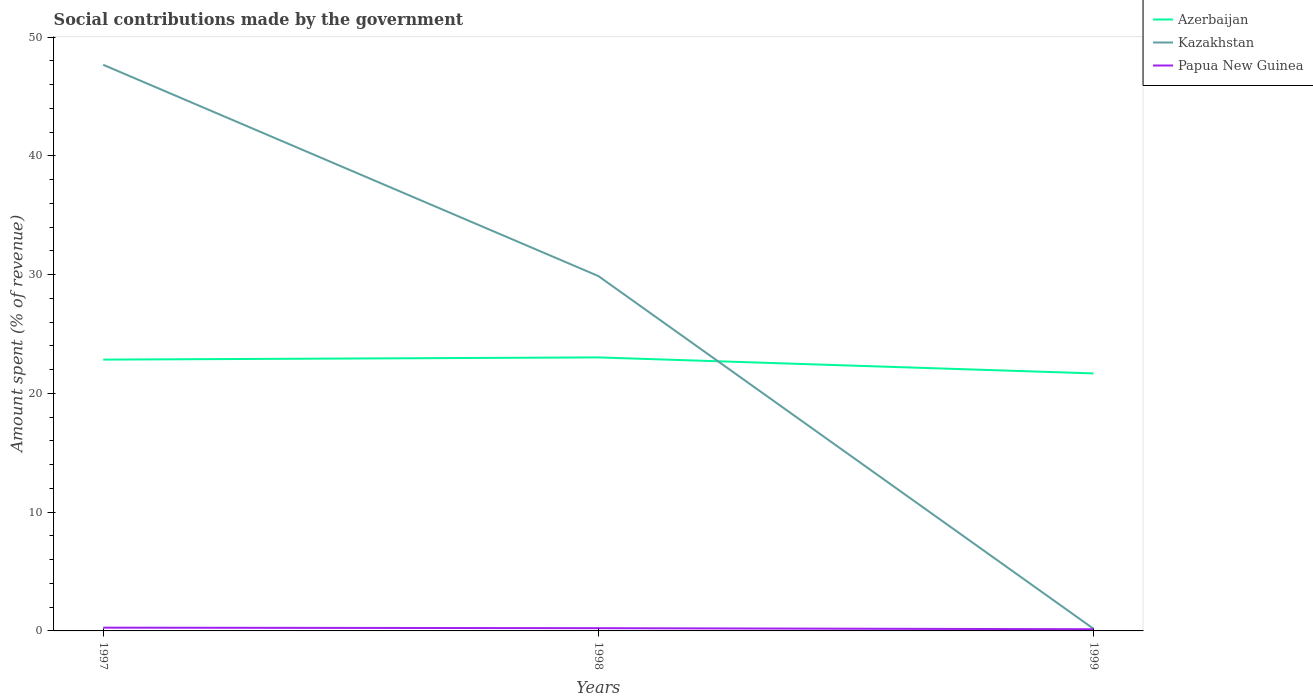Across all years, what is the maximum amount spent (in %) on social contributions in Azerbaijan?
Keep it short and to the point. 21.69. In which year was the amount spent (in %) on social contributions in Azerbaijan maximum?
Make the answer very short. 1999. What is the total amount spent (in %) on social contributions in Kazakhstan in the graph?
Keep it short and to the point. 17.79. What is the difference between the highest and the second highest amount spent (in %) on social contributions in Azerbaijan?
Your answer should be compact. 1.35. Is the amount spent (in %) on social contributions in Papua New Guinea strictly greater than the amount spent (in %) on social contributions in Azerbaijan over the years?
Your answer should be compact. Yes. How many lines are there?
Ensure brevity in your answer.  3. How many years are there in the graph?
Ensure brevity in your answer.  3. How are the legend labels stacked?
Ensure brevity in your answer.  Vertical. What is the title of the graph?
Your answer should be very brief. Social contributions made by the government. Does "Australia" appear as one of the legend labels in the graph?
Give a very brief answer. No. What is the label or title of the X-axis?
Offer a terse response. Years. What is the label or title of the Y-axis?
Provide a succinct answer. Amount spent (% of revenue). What is the Amount spent (% of revenue) of Azerbaijan in 1997?
Offer a very short reply. 22.85. What is the Amount spent (% of revenue) in Kazakhstan in 1997?
Your response must be concise. 47.67. What is the Amount spent (% of revenue) of Papua New Guinea in 1997?
Offer a very short reply. 0.28. What is the Amount spent (% of revenue) in Azerbaijan in 1998?
Keep it short and to the point. 23.03. What is the Amount spent (% of revenue) of Kazakhstan in 1998?
Make the answer very short. 29.88. What is the Amount spent (% of revenue) of Papua New Guinea in 1998?
Provide a short and direct response. 0.23. What is the Amount spent (% of revenue) of Azerbaijan in 1999?
Give a very brief answer. 21.69. What is the Amount spent (% of revenue) in Kazakhstan in 1999?
Keep it short and to the point. 0.18. What is the Amount spent (% of revenue) in Papua New Guinea in 1999?
Make the answer very short. 0.14. Across all years, what is the maximum Amount spent (% of revenue) of Azerbaijan?
Ensure brevity in your answer.  23.03. Across all years, what is the maximum Amount spent (% of revenue) of Kazakhstan?
Keep it short and to the point. 47.67. Across all years, what is the maximum Amount spent (% of revenue) of Papua New Guinea?
Provide a succinct answer. 0.28. Across all years, what is the minimum Amount spent (% of revenue) of Azerbaijan?
Ensure brevity in your answer.  21.69. Across all years, what is the minimum Amount spent (% of revenue) in Kazakhstan?
Offer a very short reply. 0.18. Across all years, what is the minimum Amount spent (% of revenue) of Papua New Guinea?
Give a very brief answer. 0.14. What is the total Amount spent (% of revenue) in Azerbaijan in the graph?
Ensure brevity in your answer.  67.57. What is the total Amount spent (% of revenue) of Kazakhstan in the graph?
Make the answer very short. 77.74. What is the total Amount spent (% of revenue) in Papua New Guinea in the graph?
Ensure brevity in your answer.  0.65. What is the difference between the Amount spent (% of revenue) in Azerbaijan in 1997 and that in 1998?
Keep it short and to the point. -0.18. What is the difference between the Amount spent (% of revenue) in Kazakhstan in 1997 and that in 1998?
Your answer should be compact. 17.79. What is the difference between the Amount spent (% of revenue) in Papua New Guinea in 1997 and that in 1998?
Your response must be concise. 0.04. What is the difference between the Amount spent (% of revenue) of Azerbaijan in 1997 and that in 1999?
Provide a succinct answer. 1.16. What is the difference between the Amount spent (% of revenue) in Kazakhstan in 1997 and that in 1999?
Provide a short and direct response. 47.49. What is the difference between the Amount spent (% of revenue) of Papua New Guinea in 1997 and that in 1999?
Keep it short and to the point. 0.13. What is the difference between the Amount spent (% of revenue) in Azerbaijan in 1998 and that in 1999?
Make the answer very short. 1.35. What is the difference between the Amount spent (% of revenue) of Kazakhstan in 1998 and that in 1999?
Provide a short and direct response. 29.7. What is the difference between the Amount spent (% of revenue) of Papua New Guinea in 1998 and that in 1999?
Give a very brief answer. 0.09. What is the difference between the Amount spent (% of revenue) in Azerbaijan in 1997 and the Amount spent (% of revenue) in Kazakhstan in 1998?
Ensure brevity in your answer.  -7.04. What is the difference between the Amount spent (% of revenue) in Azerbaijan in 1997 and the Amount spent (% of revenue) in Papua New Guinea in 1998?
Give a very brief answer. 22.62. What is the difference between the Amount spent (% of revenue) in Kazakhstan in 1997 and the Amount spent (% of revenue) in Papua New Guinea in 1998?
Give a very brief answer. 47.44. What is the difference between the Amount spent (% of revenue) of Azerbaijan in 1997 and the Amount spent (% of revenue) of Kazakhstan in 1999?
Provide a succinct answer. 22.67. What is the difference between the Amount spent (% of revenue) of Azerbaijan in 1997 and the Amount spent (% of revenue) of Papua New Guinea in 1999?
Provide a succinct answer. 22.71. What is the difference between the Amount spent (% of revenue) of Kazakhstan in 1997 and the Amount spent (% of revenue) of Papua New Guinea in 1999?
Offer a very short reply. 47.53. What is the difference between the Amount spent (% of revenue) in Azerbaijan in 1998 and the Amount spent (% of revenue) in Kazakhstan in 1999?
Keep it short and to the point. 22.85. What is the difference between the Amount spent (% of revenue) in Azerbaijan in 1998 and the Amount spent (% of revenue) in Papua New Guinea in 1999?
Keep it short and to the point. 22.89. What is the difference between the Amount spent (% of revenue) of Kazakhstan in 1998 and the Amount spent (% of revenue) of Papua New Guinea in 1999?
Offer a very short reply. 29.74. What is the average Amount spent (% of revenue) in Azerbaijan per year?
Offer a terse response. 22.52. What is the average Amount spent (% of revenue) of Kazakhstan per year?
Offer a terse response. 25.91. What is the average Amount spent (% of revenue) in Papua New Guinea per year?
Offer a very short reply. 0.22. In the year 1997, what is the difference between the Amount spent (% of revenue) of Azerbaijan and Amount spent (% of revenue) of Kazakhstan?
Provide a short and direct response. -24.83. In the year 1997, what is the difference between the Amount spent (% of revenue) in Azerbaijan and Amount spent (% of revenue) in Papua New Guinea?
Make the answer very short. 22.57. In the year 1997, what is the difference between the Amount spent (% of revenue) of Kazakhstan and Amount spent (% of revenue) of Papua New Guinea?
Provide a succinct answer. 47.4. In the year 1998, what is the difference between the Amount spent (% of revenue) in Azerbaijan and Amount spent (% of revenue) in Kazakhstan?
Ensure brevity in your answer.  -6.85. In the year 1998, what is the difference between the Amount spent (% of revenue) in Azerbaijan and Amount spent (% of revenue) in Papua New Guinea?
Keep it short and to the point. 22.8. In the year 1998, what is the difference between the Amount spent (% of revenue) in Kazakhstan and Amount spent (% of revenue) in Papua New Guinea?
Give a very brief answer. 29.65. In the year 1999, what is the difference between the Amount spent (% of revenue) of Azerbaijan and Amount spent (% of revenue) of Kazakhstan?
Your answer should be very brief. 21.5. In the year 1999, what is the difference between the Amount spent (% of revenue) in Azerbaijan and Amount spent (% of revenue) in Papua New Guinea?
Your response must be concise. 21.54. In the year 1999, what is the difference between the Amount spent (% of revenue) of Kazakhstan and Amount spent (% of revenue) of Papua New Guinea?
Make the answer very short. 0.04. What is the ratio of the Amount spent (% of revenue) of Azerbaijan in 1997 to that in 1998?
Make the answer very short. 0.99. What is the ratio of the Amount spent (% of revenue) in Kazakhstan in 1997 to that in 1998?
Your response must be concise. 1.6. What is the ratio of the Amount spent (% of revenue) in Papua New Guinea in 1997 to that in 1998?
Ensure brevity in your answer.  1.19. What is the ratio of the Amount spent (% of revenue) of Azerbaijan in 1997 to that in 1999?
Keep it short and to the point. 1.05. What is the ratio of the Amount spent (% of revenue) in Kazakhstan in 1997 to that in 1999?
Make the answer very short. 263.04. What is the ratio of the Amount spent (% of revenue) of Papua New Guinea in 1997 to that in 1999?
Provide a short and direct response. 1.94. What is the ratio of the Amount spent (% of revenue) in Azerbaijan in 1998 to that in 1999?
Ensure brevity in your answer.  1.06. What is the ratio of the Amount spent (% of revenue) in Kazakhstan in 1998 to that in 1999?
Provide a succinct answer. 164.88. What is the ratio of the Amount spent (% of revenue) of Papua New Guinea in 1998 to that in 1999?
Provide a succinct answer. 1.63. What is the difference between the highest and the second highest Amount spent (% of revenue) of Azerbaijan?
Your answer should be very brief. 0.18. What is the difference between the highest and the second highest Amount spent (% of revenue) of Kazakhstan?
Provide a succinct answer. 17.79. What is the difference between the highest and the second highest Amount spent (% of revenue) in Papua New Guinea?
Your answer should be very brief. 0.04. What is the difference between the highest and the lowest Amount spent (% of revenue) of Azerbaijan?
Make the answer very short. 1.35. What is the difference between the highest and the lowest Amount spent (% of revenue) in Kazakhstan?
Your answer should be compact. 47.49. What is the difference between the highest and the lowest Amount spent (% of revenue) in Papua New Guinea?
Offer a very short reply. 0.13. 